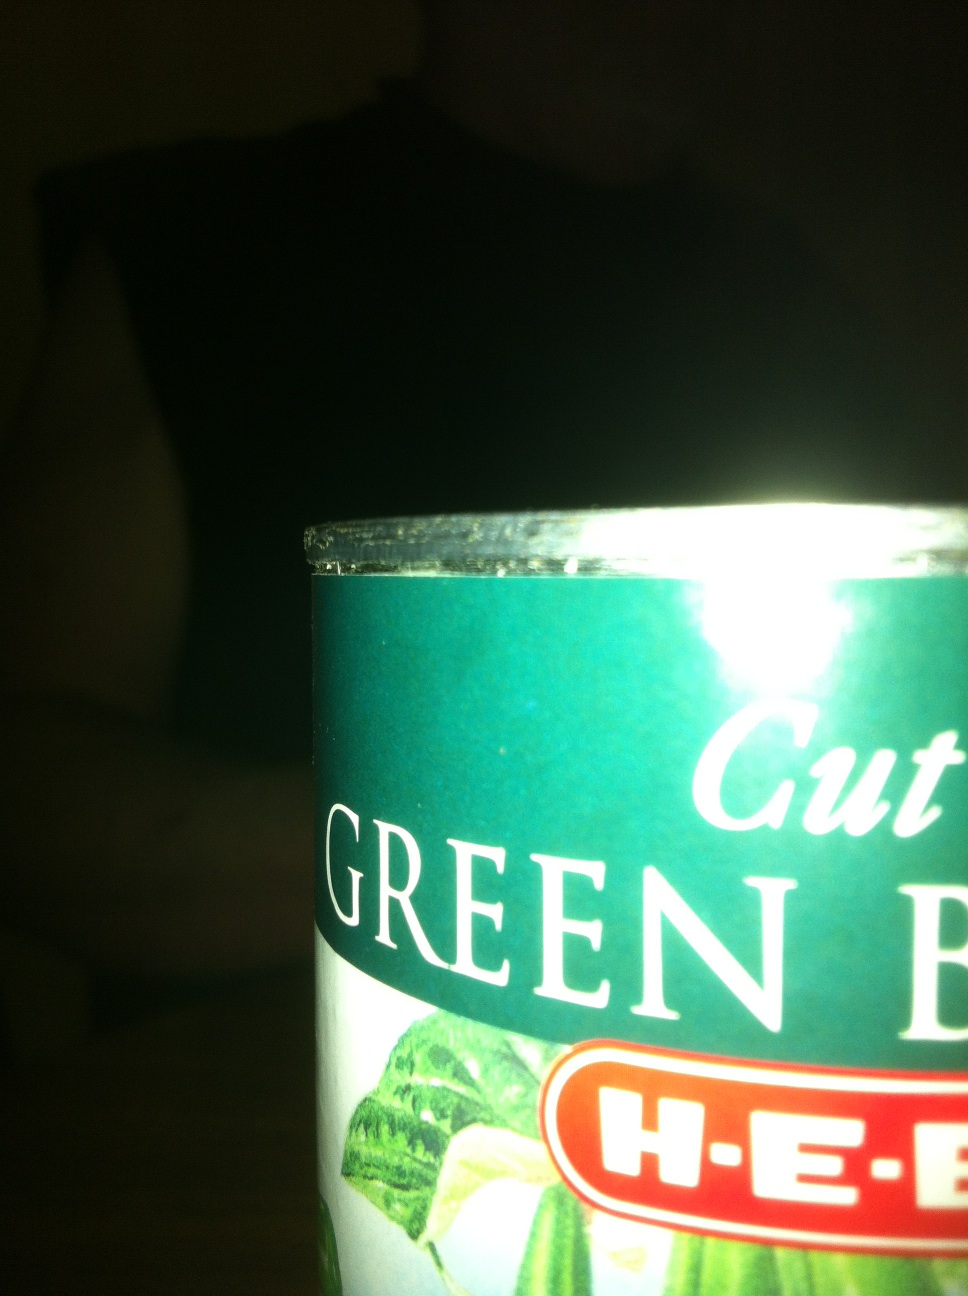Can you tell more about the nutrition information of cut green beans? Cut green beans, as with most green vegetables, are low in calories but high in fiber and vitamins. They typically contain vitamin C, vitamin K, and are also a good source of folate and fiber. However, exact nutrition details would depend on the specific brand and preparation method. 